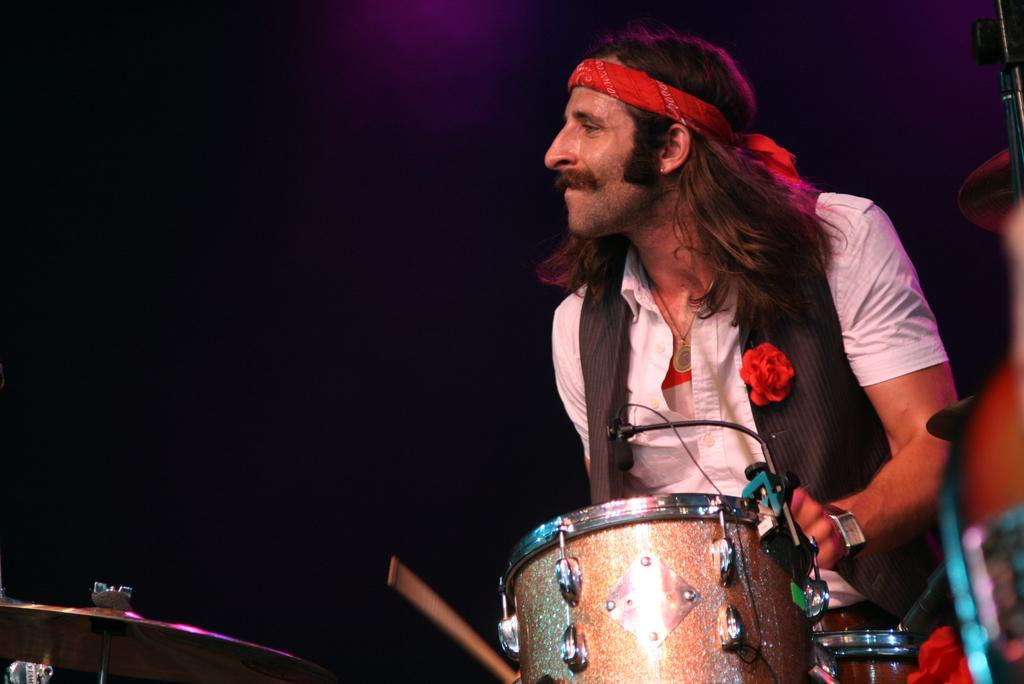What is the main subject of the image? There is a man in the image. Can you describe the man's appearance? The man has long hair. What is the man doing in the image? The man is playing drums. Who is the man looking at? The man is looking at someone. What type of hook is the man using to play the drums in the image? There is no hook present in the image; the man is playing drums with his hands or drumsticks. 